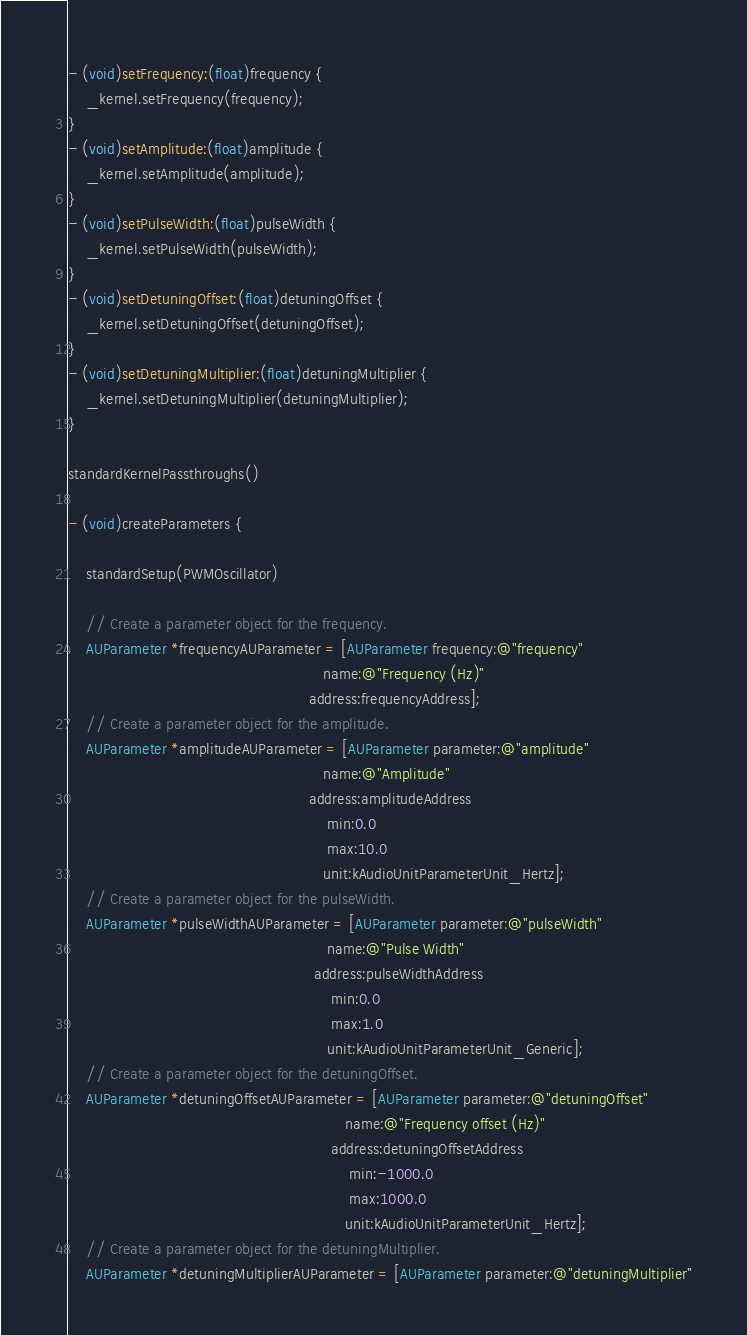<code> <loc_0><loc_0><loc_500><loc_500><_ObjectiveC_>- (void)setFrequency:(float)frequency {
    _kernel.setFrequency(frequency);
}
- (void)setAmplitude:(float)amplitude {
    _kernel.setAmplitude(amplitude);
}
- (void)setPulseWidth:(float)pulseWidth {
    _kernel.setPulseWidth(pulseWidth);
}
- (void)setDetuningOffset:(float)detuningOffset {
    _kernel.setDetuningOffset(detuningOffset);
}
- (void)setDetuningMultiplier:(float)detuningMultiplier {
    _kernel.setDetuningMultiplier(detuningMultiplier);
}

standardKernelPassthroughs()

- (void)createParameters {

    standardSetup(PWMOscillator)

    // Create a parameter object for the frequency.
    AUParameter *frequencyAUParameter = [AUParameter frequency:@"frequency"
                                                          name:@"Frequency (Hz)"
                                                       address:frequencyAddress];
    // Create a parameter object for the amplitude.
    AUParameter *amplitudeAUParameter = [AUParameter parameter:@"amplitude"
                                                          name:@"Amplitude"
                                                       address:amplitudeAddress
                                                           min:0.0
                                                           max:10.0
                                                          unit:kAudioUnitParameterUnit_Hertz];
    // Create a parameter object for the pulseWidth.
    AUParameter *pulseWidthAUParameter = [AUParameter parameter:@"pulseWidth"
                                                           name:@"Pulse Width"
                                                        address:pulseWidthAddress
                                                            min:0.0
                                                            max:1.0
                                                           unit:kAudioUnitParameterUnit_Generic];
    // Create a parameter object for the detuningOffset.
    AUParameter *detuningOffsetAUParameter = [AUParameter parameter:@"detuningOffset"
                                                               name:@"Frequency offset (Hz)"
                                                            address:detuningOffsetAddress
                                                                min:-1000.0
                                                                max:1000.0
                                                               unit:kAudioUnitParameterUnit_Hertz];
    // Create a parameter object for the detuningMultiplier.
    AUParameter *detuningMultiplierAUParameter = [AUParameter parameter:@"detuningMultiplier"</code> 